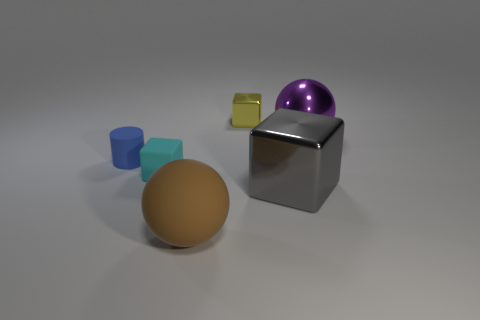What textures can be observed on the different objects in the image? The brown sphere has a smooth, matte texture, the lilac-hued sphere appears glossy, the blue cube has a satiny finish, and the metallic cube has a reflective, shiny surface. The tiny yellow block seems to have a solid, possibly plastic matte texture. 